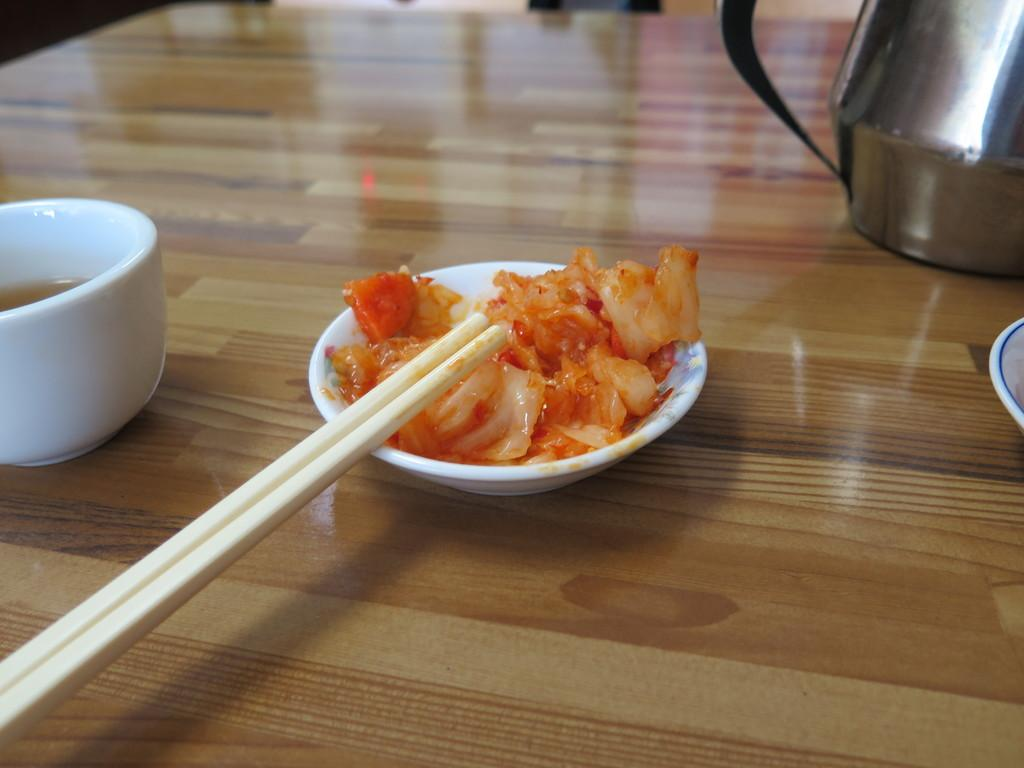What is in the bowl that is visible in the image? There is a bowl of food in the image. Where is the bowl of food located? The bowl of food is placed on a table. What type of wilderness can be seen in the background of the image? There is no wilderness visible in the image; it only shows a bowl of food placed on a table. 